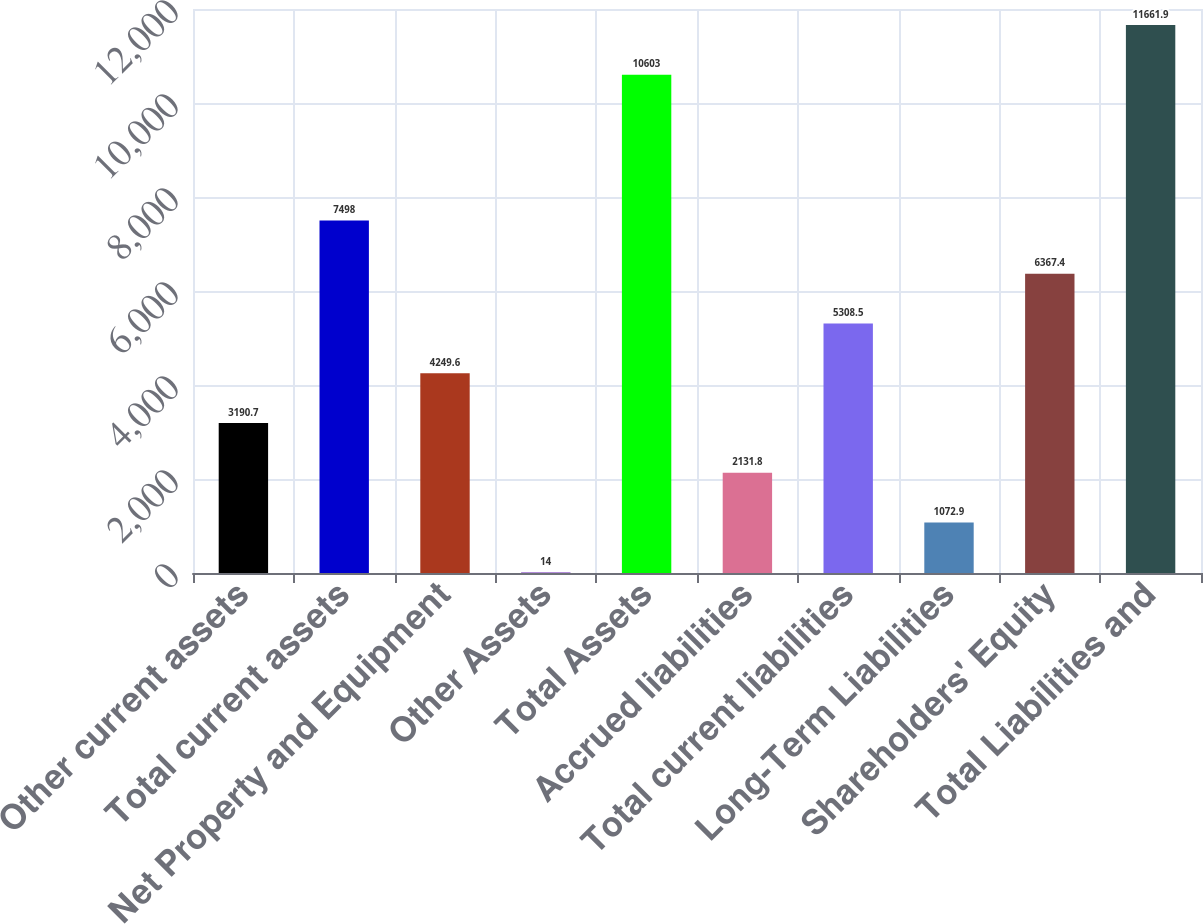<chart> <loc_0><loc_0><loc_500><loc_500><bar_chart><fcel>Other current assets<fcel>Total current assets<fcel>Net Property and Equipment<fcel>Other Assets<fcel>Total Assets<fcel>Accrued liabilities<fcel>Total current liabilities<fcel>Long-Term Liabilities<fcel>Shareholders' Equity<fcel>Total Liabilities and<nl><fcel>3190.7<fcel>7498<fcel>4249.6<fcel>14<fcel>10603<fcel>2131.8<fcel>5308.5<fcel>1072.9<fcel>6367.4<fcel>11661.9<nl></chart> 